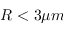<formula> <loc_0><loc_0><loc_500><loc_500>R < 3 \mu m</formula> 